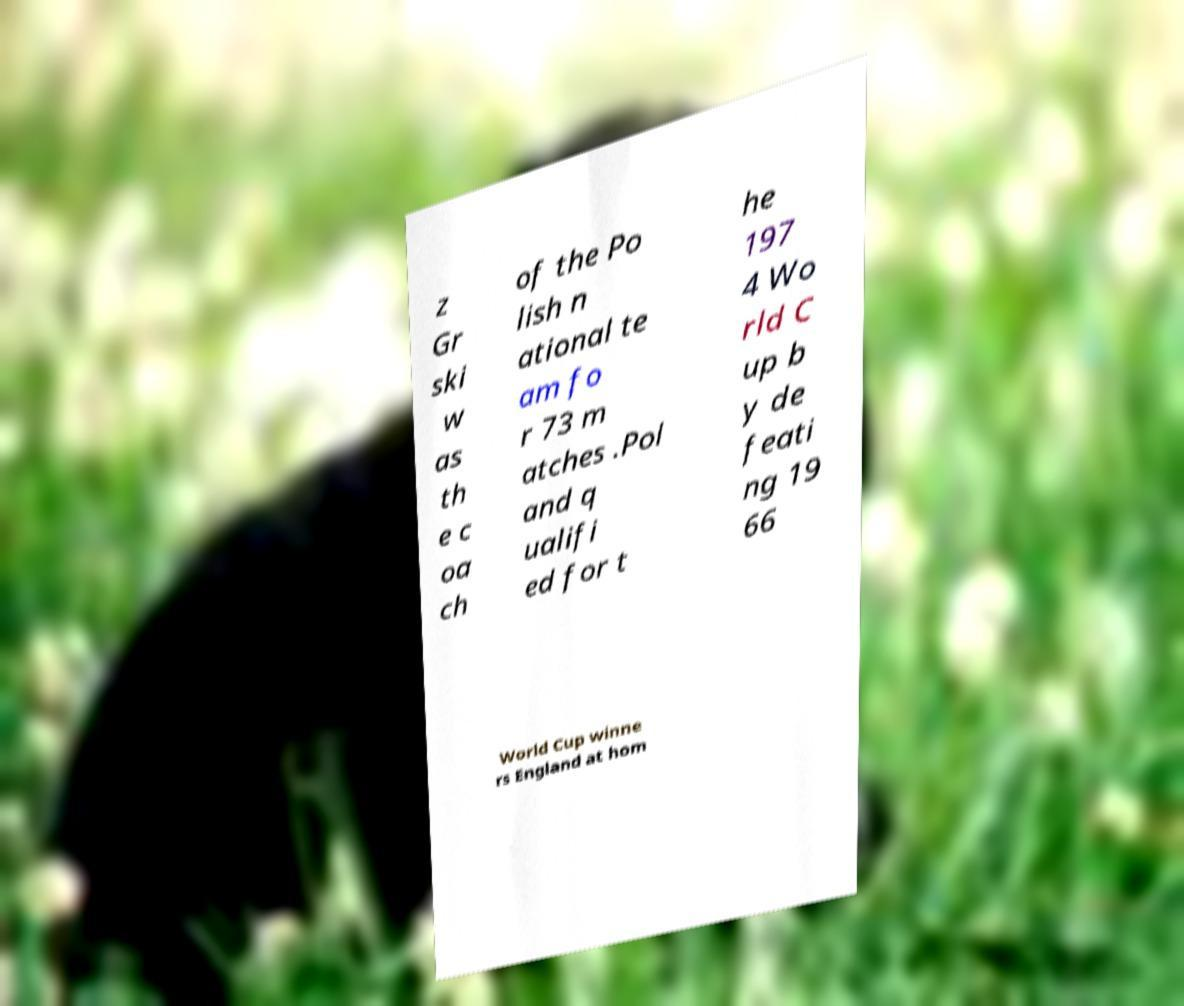Please identify and transcribe the text found in this image. z Gr ski w as th e c oa ch of the Po lish n ational te am fo r 73 m atches .Pol and q ualifi ed for t he 197 4 Wo rld C up b y de feati ng 19 66 World Cup winne rs England at hom 